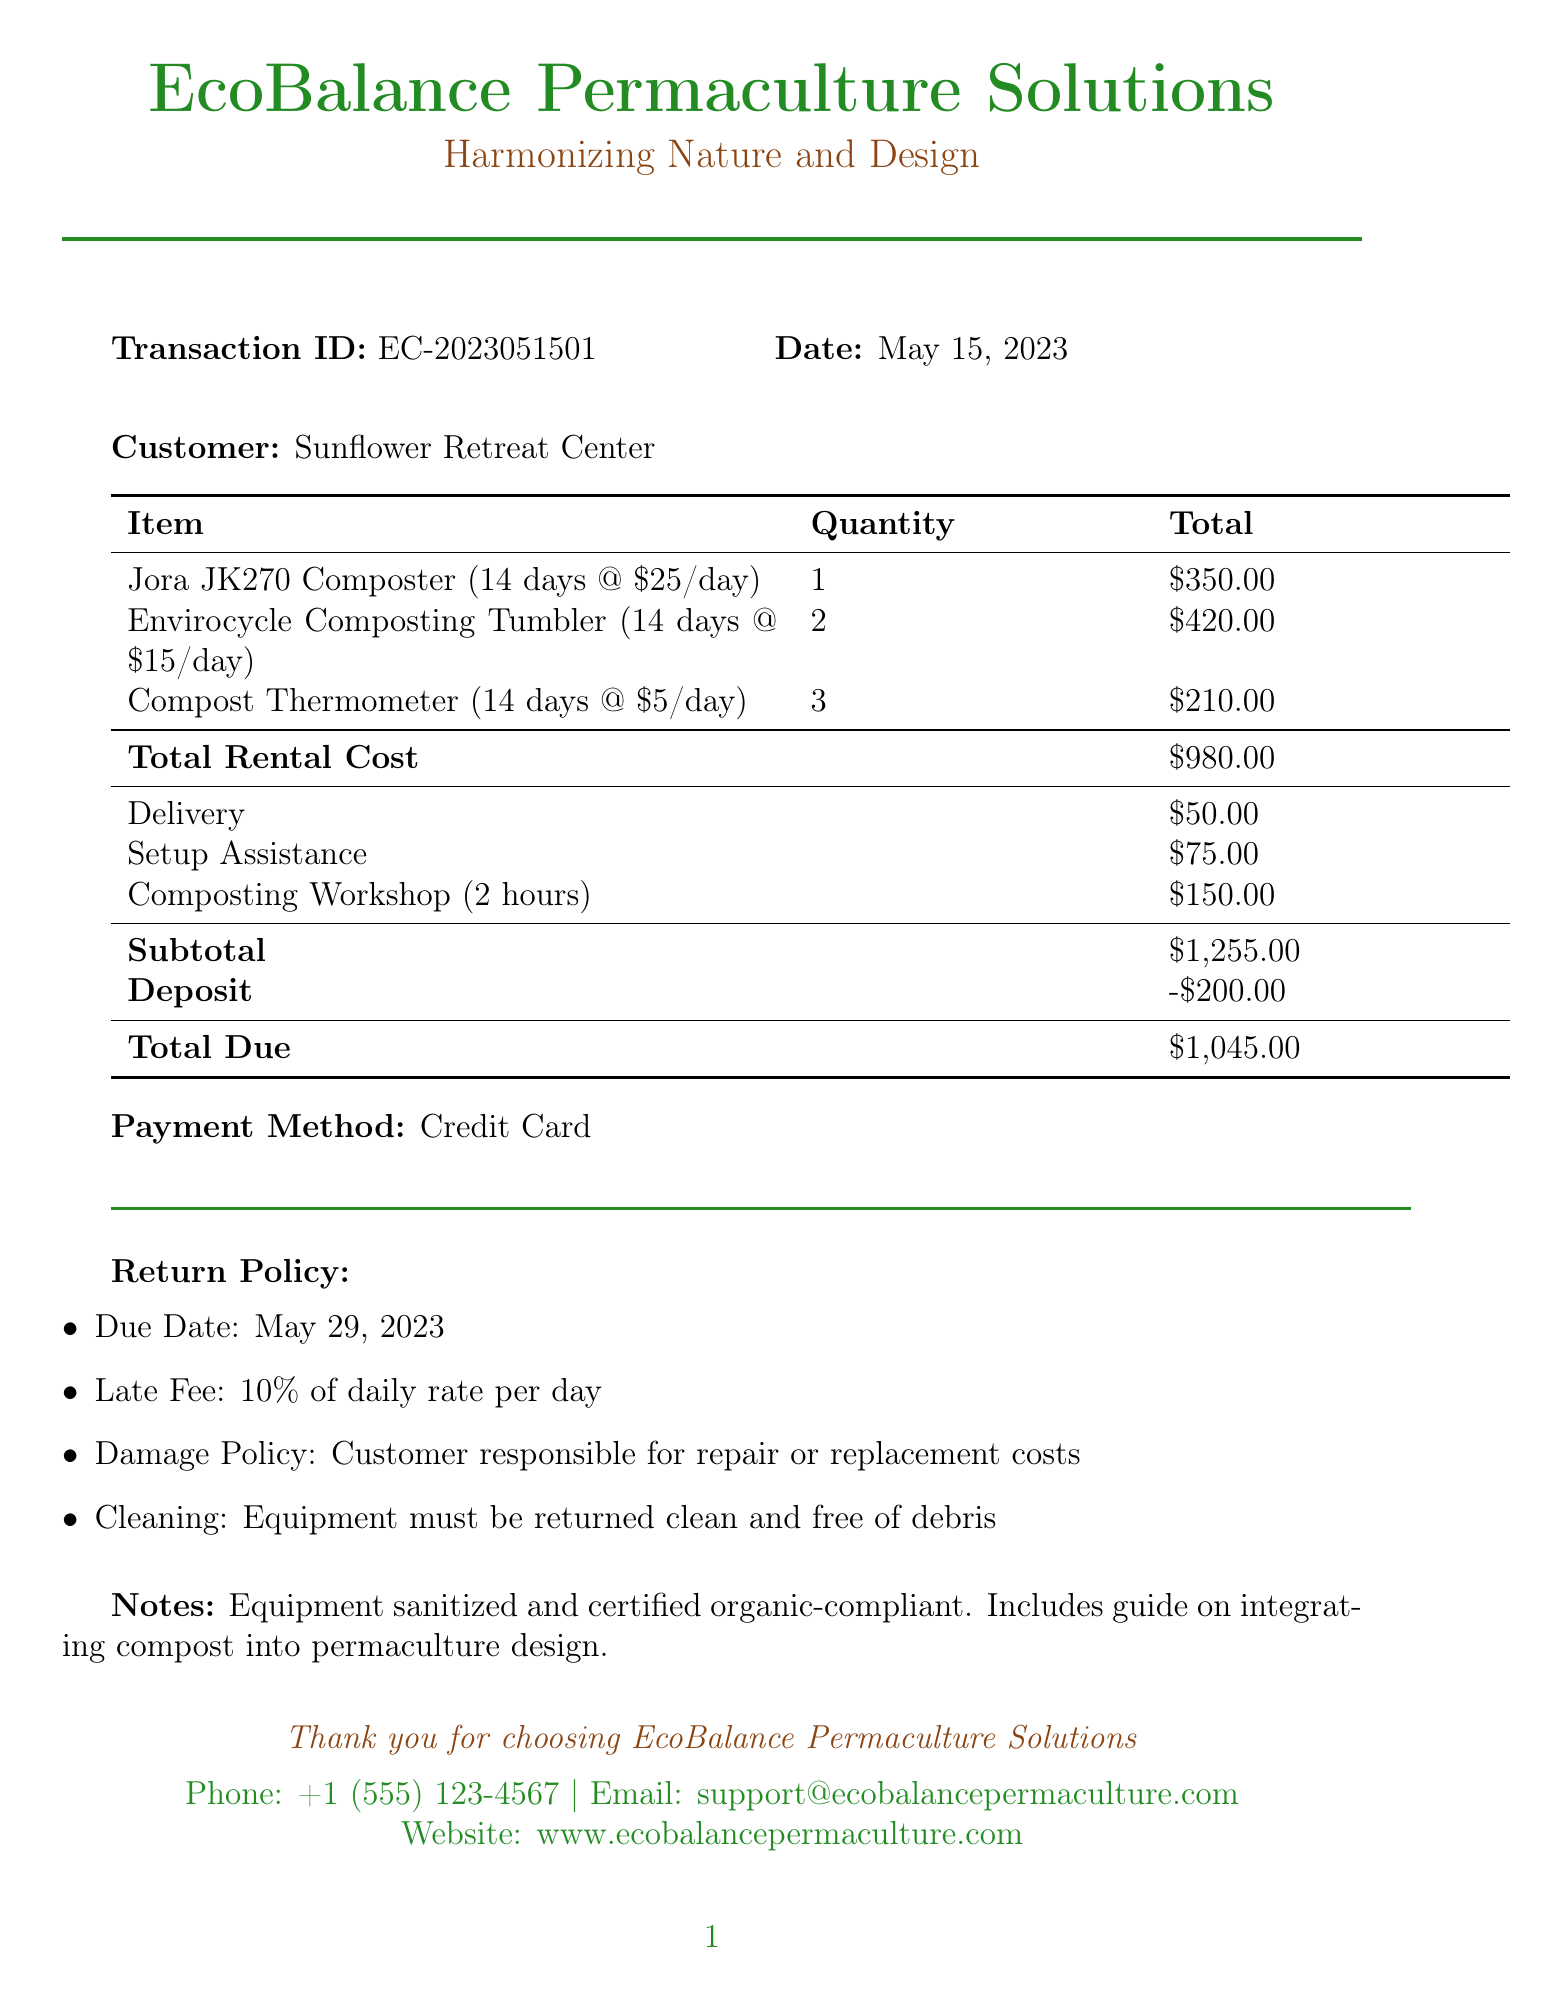What is the business name? The business name is clearly stated at the top of the document.
Answer: EcoBalance Permaculture Solutions Who is the customer? The customer name appears below the transaction details.
Answer: Sunflower Retreat Center What is the transaction date? The transaction date is indicated in the document.
Answer: May 15, 2023 What is the total rental cost? The total rental cost is calculated from the rental items and displayed in the table.
Answer: $980.00 What is the deposit amount? The deposit amount is listed separately in the financial summary.
Answer: $200.00 When is the due date for returning the equipment? The due date for the equipment return is explicitly mentioned in the return policy section.
Answer: May 29, 2023 What is the late fee rate? The late fee is described in the return policy as a percentage.
Answer: 10% of daily rate per day What additional service costs $150.00? The costs for services are listed, with their respective prices in the additional services section.
Answer: Composting Workshop (2 hours) What should the equipment condition be upon return? The return policy specifies the condition of the equipment upon return.
Answer: Clean and free of debris 